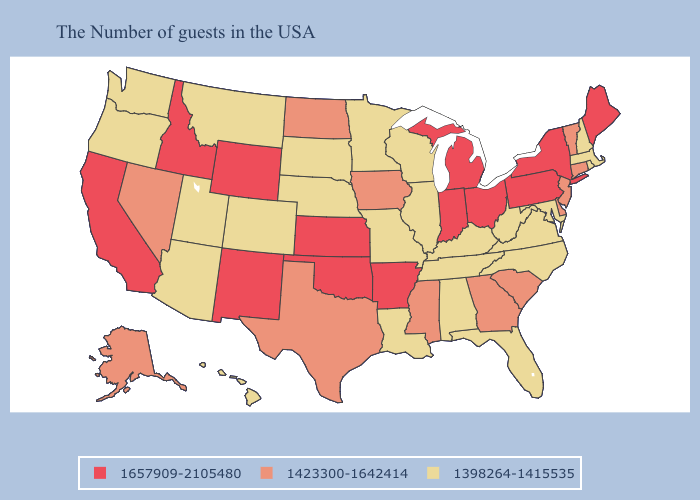Name the states that have a value in the range 1398264-1415535?
Answer briefly. Massachusetts, Rhode Island, New Hampshire, Maryland, Virginia, North Carolina, West Virginia, Florida, Kentucky, Alabama, Tennessee, Wisconsin, Illinois, Louisiana, Missouri, Minnesota, Nebraska, South Dakota, Colorado, Utah, Montana, Arizona, Washington, Oregon, Hawaii. Name the states that have a value in the range 1657909-2105480?
Give a very brief answer. Maine, New York, Pennsylvania, Ohio, Michigan, Indiana, Arkansas, Kansas, Oklahoma, Wyoming, New Mexico, Idaho, California. Among the states that border Minnesota , does North Dakota have the highest value?
Write a very short answer. Yes. What is the value of Louisiana?
Quick response, please. 1398264-1415535. What is the highest value in the USA?
Answer briefly. 1657909-2105480. What is the value of Maine?
Write a very short answer. 1657909-2105480. Which states have the lowest value in the Northeast?
Quick response, please. Massachusetts, Rhode Island, New Hampshire. Name the states that have a value in the range 1423300-1642414?
Quick response, please. Vermont, Connecticut, New Jersey, Delaware, South Carolina, Georgia, Mississippi, Iowa, Texas, North Dakota, Nevada, Alaska. What is the lowest value in states that border Iowa?
Quick response, please. 1398264-1415535. Name the states that have a value in the range 1423300-1642414?
Keep it brief. Vermont, Connecticut, New Jersey, Delaware, South Carolina, Georgia, Mississippi, Iowa, Texas, North Dakota, Nevada, Alaska. Among the states that border Florida , does Alabama have the highest value?
Be succinct. No. Does Nebraska have the lowest value in the MidWest?
Answer briefly. Yes. What is the value of Virginia?
Quick response, please. 1398264-1415535. What is the lowest value in the USA?
Short answer required. 1398264-1415535. Does the map have missing data?
Be succinct. No. 